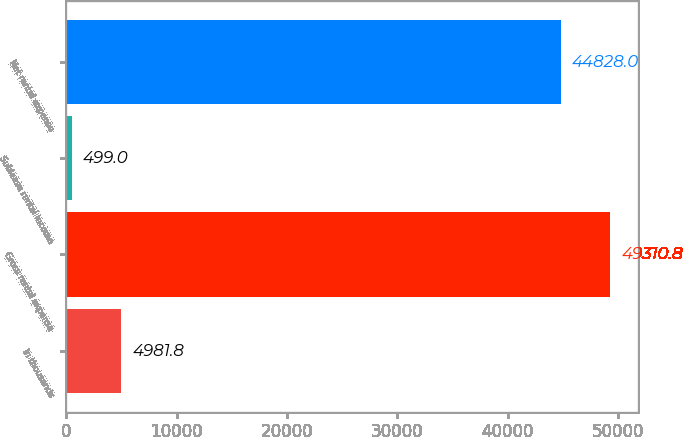Convert chart to OTSL. <chart><loc_0><loc_0><loc_500><loc_500><bar_chart><fcel>In thousands<fcel>Gross rental expense<fcel>Sublease rental income<fcel>Net rental expense<nl><fcel>4981.8<fcel>49310.8<fcel>499<fcel>44828<nl></chart> 